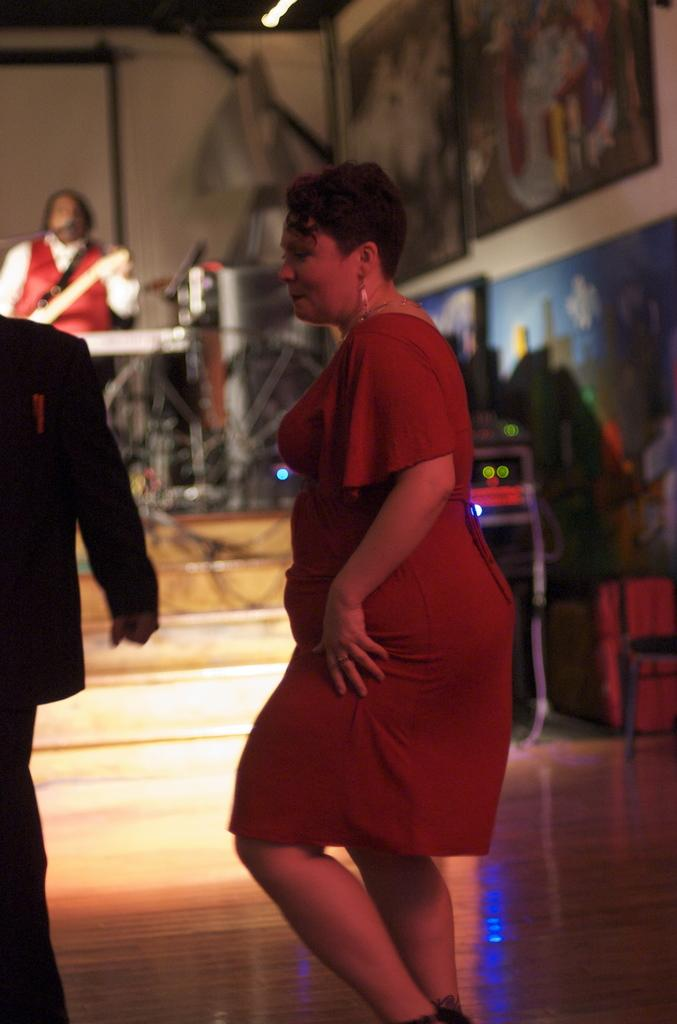What are the people in the image doing? The people in the image are on the floor. Can you describe the background of the image? The background of the image is blurry. Is there anyone else visible in the image besides the people on the floor? Yes, there is a person visible in the background. What type of items can be seen in the image? Devices, cables, boards on the wall, and other objects are present in the image. What type of behavior can be observed from the knife in the image? There is no knife present in the image, so it is not possible to observe any behavior from it. 